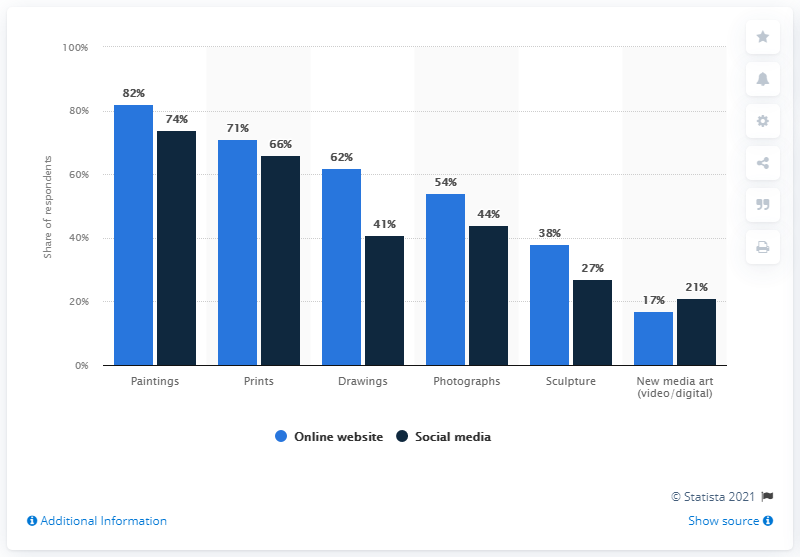Give some essential details in this illustration. The value of the highest dark blue bar is 74. During the COVID-19 pandemic in 2020, paintings were the most commonly purchased fine art mediums online. The difference between paintings and drawings in an online website category is that paintings are created using oils, acrylics, or other forms of paint, while drawings are created using pencils, charcoal, or other forms of graphite. 